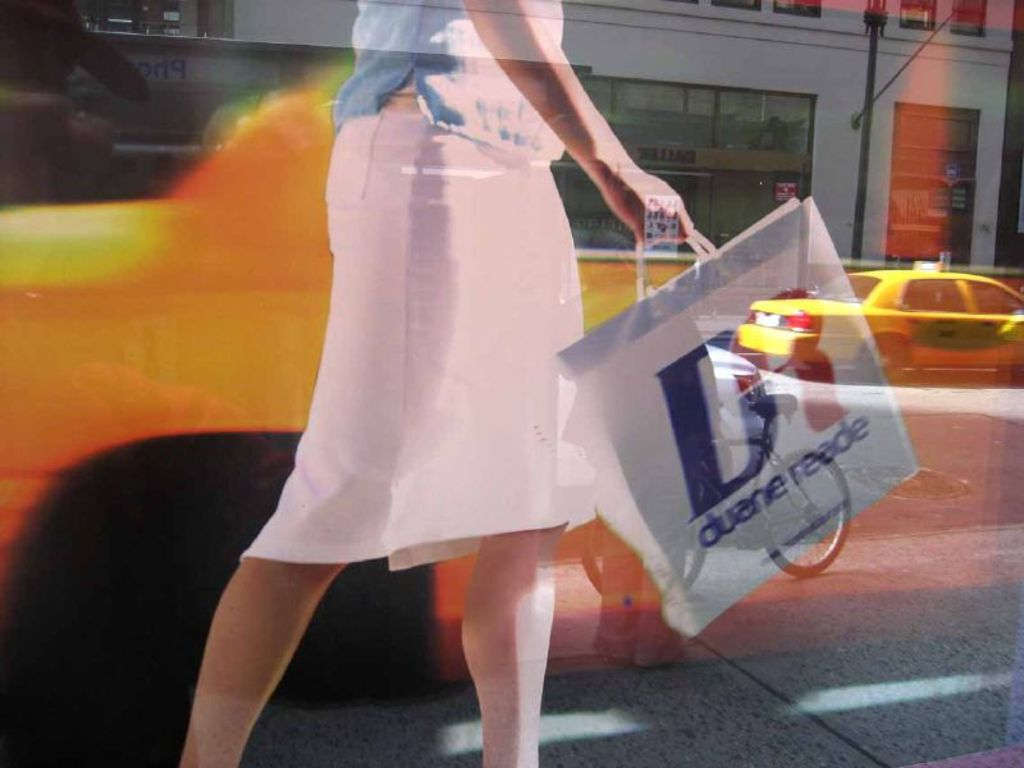Provide a one-sentence caption for the provided image.
Reference OCR token: on9, ae A woman in a pink skirt swinging a shopping bag from Duane Reade. 